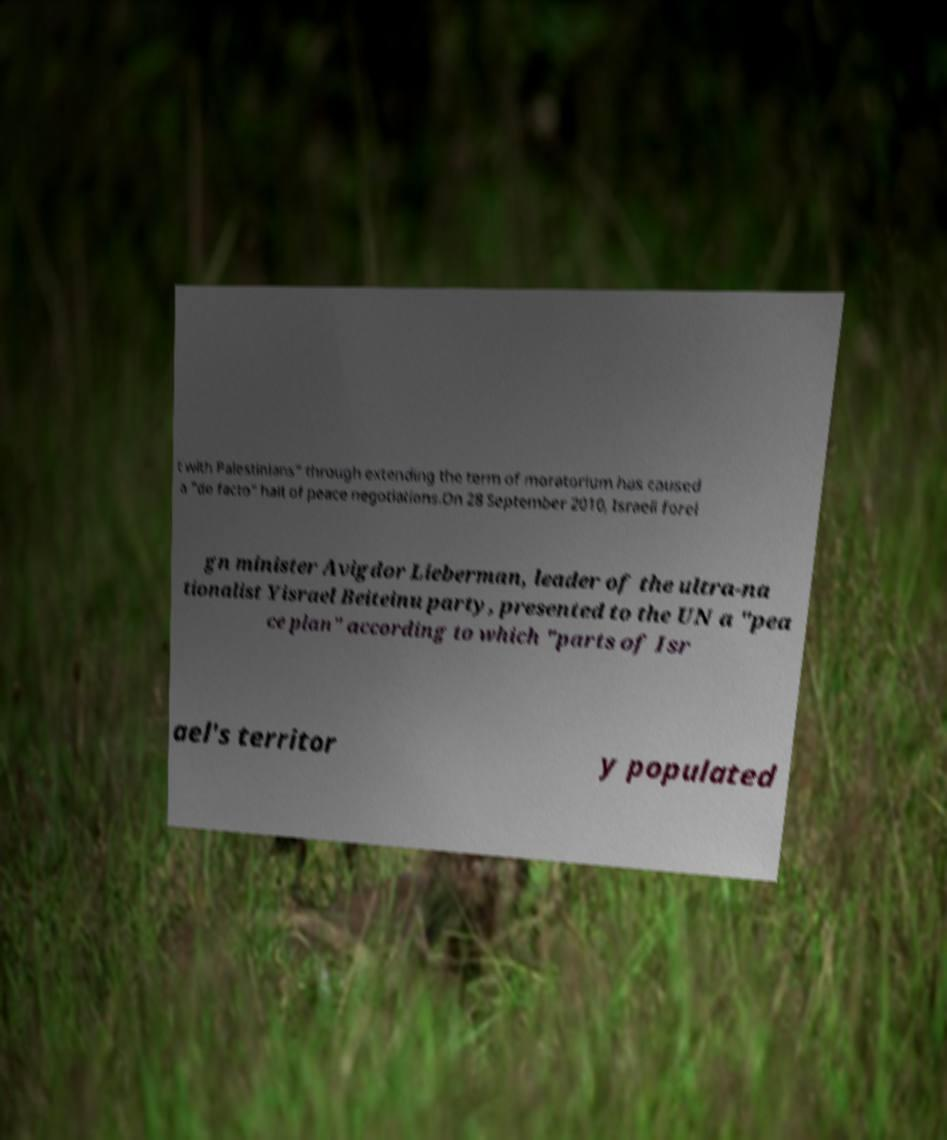I need the written content from this picture converted into text. Can you do that? t with Palestinians" through extending the term of moratorium has caused a "de facto" halt of peace negotiations.On 28 September 2010, Israeli forei gn minister Avigdor Lieberman, leader of the ultra-na tionalist Yisrael Beiteinu party, presented to the UN a ″pea ce plan″ according to which ″parts of Isr ael's territor y populated 